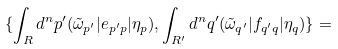Convert formula to latex. <formula><loc_0><loc_0><loc_500><loc_500>\{ \int _ { R } d ^ { n } p ^ { \prime } ( \tilde { \omega } _ { p ^ { \prime } } | e _ { p ^ { \prime } p } | \eta _ { p } ) , \int _ { R ^ { \prime } } d ^ { n } q ^ { \prime } ( \tilde { \omega } _ { q ^ { \prime } } | f _ { q ^ { \prime } q } | \eta _ { q } ) \} =</formula> 